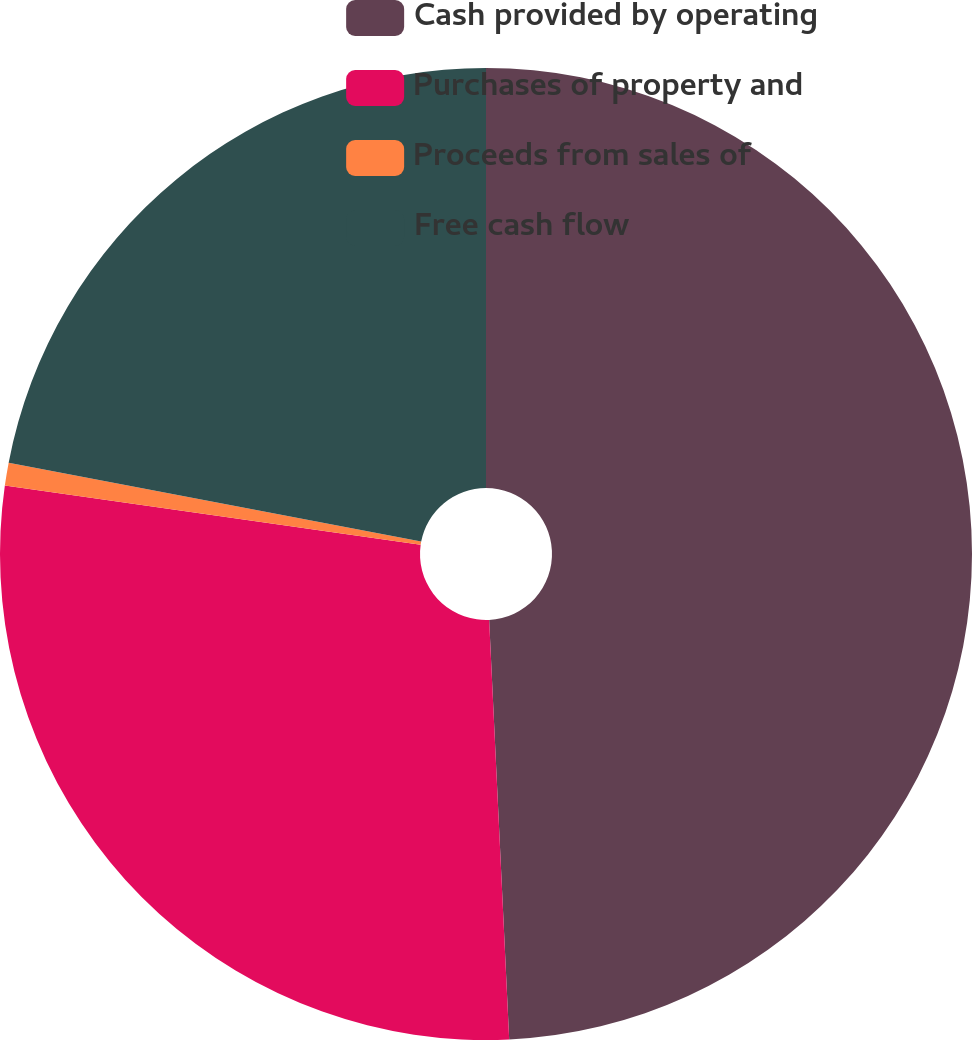Convert chart. <chart><loc_0><loc_0><loc_500><loc_500><pie_chart><fcel>Cash provided by operating<fcel>Purchases of property and<fcel>Proceeds from sales of<fcel>Free cash flow<nl><fcel>49.24%<fcel>28.01%<fcel>0.76%<fcel>21.99%<nl></chart> 